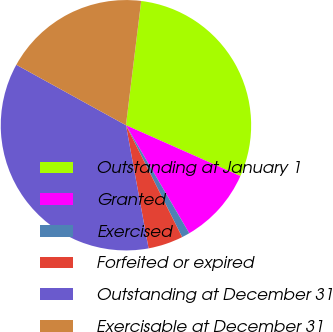Convert chart to OTSL. <chart><loc_0><loc_0><loc_500><loc_500><pie_chart><fcel>Outstanding at January 1<fcel>Granted<fcel>Exercised<fcel>Forfeited or expired<fcel>Outstanding at December 31<fcel>Exercisable at December 31<nl><fcel>29.71%<fcel>9.91%<fcel>1.03%<fcel>4.52%<fcel>35.91%<fcel>18.92%<nl></chart> 